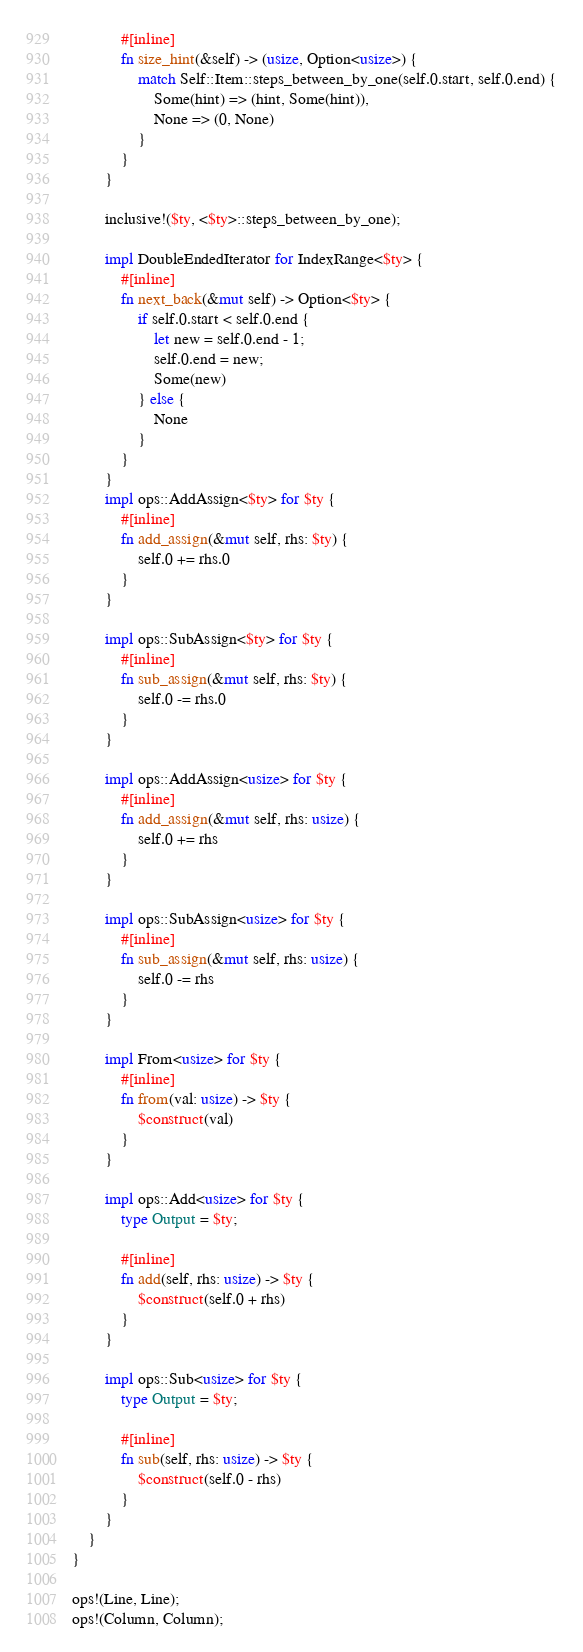Convert code to text. <code><loc_0><loc_0><loc_500><loc_500><_Rust_>            #[inline]
            fn size_hint(&self) -> (usize, Option<usize>) {
                match Self::Item::steps_between_by_one(self.0.start, self.0.end) {
                    Some(hint) => (hint, Some(hint)),
                    None => (0, None)
                }
            }
        }

        inclusive!($ty, <$ty>::steps_between_by_one);

        impl DoubleEndedIterator for IndexRange<$ty> {
            #[inline]
            fn next_back(&mut self) -> Option<$ty> {
                if self.0.start < self.0.end {
                    let new = self.0.end - 1;
                    self.0.end = new;
                    Some(new)
                } else {
                    None
                }
            }
        }
        impl ops::AddAssign<$ty> for $ty {
            #[inline]
            fn add_assign(&mut self, rhs: $ty) {
                self.0 += rhs.0
            }
        }

        impl ops::SubAssign<$ty> for $ty {
            #[inline]
            fn sub_assign(&mut self, rhs: $ty) {
                self.0 -= rhs.0
            }
        }

        impl ops::AddAssign<usize> for $ty {
            #[inline]
            fn add_assign(&mut self, rhs: usize) {
                self.0 += rhs
            }
        }

        impl ops::SubAssign<usize> for $ty {
            #[inline]
            fn sub_assign(&mut self, rhs: usize) {
                self.0 -= rhs
            }
        }

        impl From<usize> for $ty {
            #[inline]
            fn from(val: usize) -> $ty {
                $construct(val)
            }
        }

        impl ops::Add<usize> for $ty {
            type Output = $ty;

            #[inline]
            fn add(self, rhs: usize) -> $ty {
                $construct(self.0 + rhs)
            }
        }

        impl ops::Sub<usize> for $ty {
            type Output = $ty;

            #[inline]
            fn sub(self, rhs: usize) -> $ty {
                $construct(self.0 - rhs)
            }
        }
    }
}

ops!(Line, Line);
ops!(Column, Column);</code> 